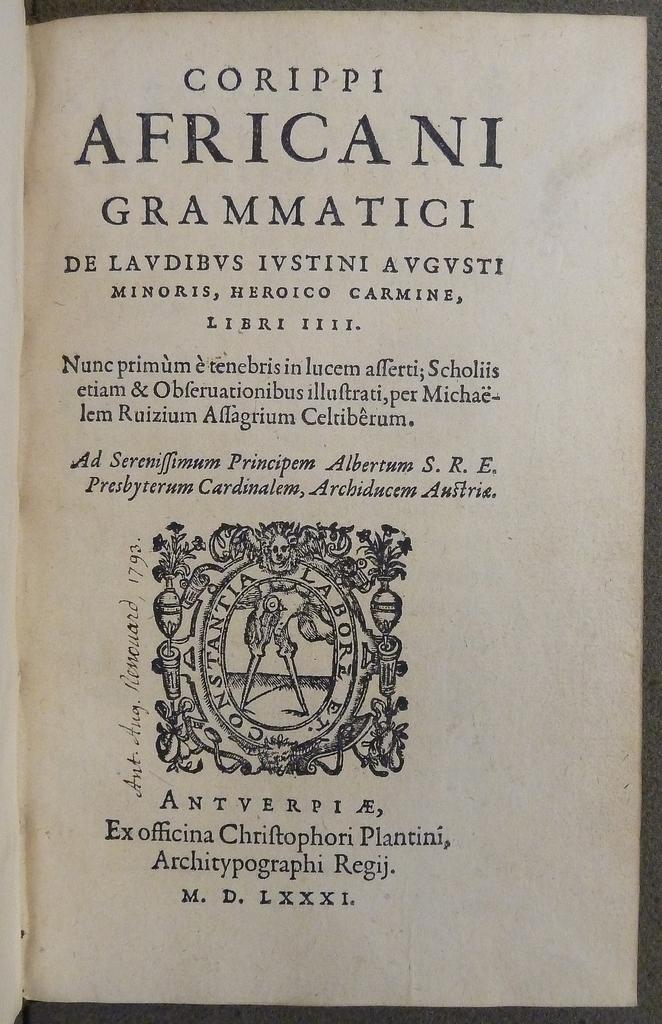Provide a one-sentence caption for the provided image. Corippi Africani Grammatici is the title shown for this open book. 